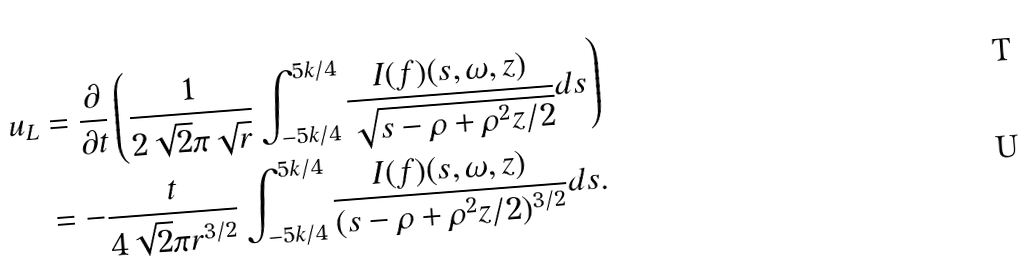<formula> <loc_0><loc_0><loc_500><loc_500>u _ { L } & = \frac { \partial } { \partial t } \left ( \frac { 1 } { 2 \sqrt { 2 } \pi \sqrt { r } } \int _ { - 5 k / 4 } ^ { 5 k / 4 } \frac { I ( f ) ( s , \omega , z ) } { \sqrt { s - \rho + \rho ^ { 2 } z / 2 } } d s \right ) \\ & = - \frac { t } { 4 \sqrt { 2 } \pi r ^ { 3 / 2 } } \int _ { - 5 k / 4 } ^ { 5 k / 4 } \frac { I ( f ) ( s , \omega , z ) } { ( s - \rho + \rho ^ { 2 } z / 2 ) ^ { 3 / 2 } } d s .</formula> 